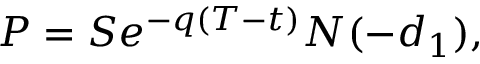Convert formula to latex. <formula><loc_0><loc_0><loc_500><loc_500>P = S e ^ { - q ( T - t ) } N ( - d _ { 1 } ) ,</formula> 